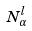<formula> <loc_0><loc_0><loc_500><loc_500>N _ { \alpha } ^ { l }</formula> 